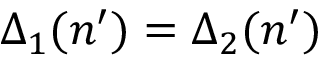Convert formula to latex. <formula><loc_0><loc_0><loc_500><loc_500>\Delta _ { 1 } ( n ^ { \prime } ) = \Delta _ { 2 } ( n ^ { \prime } )</formula> 